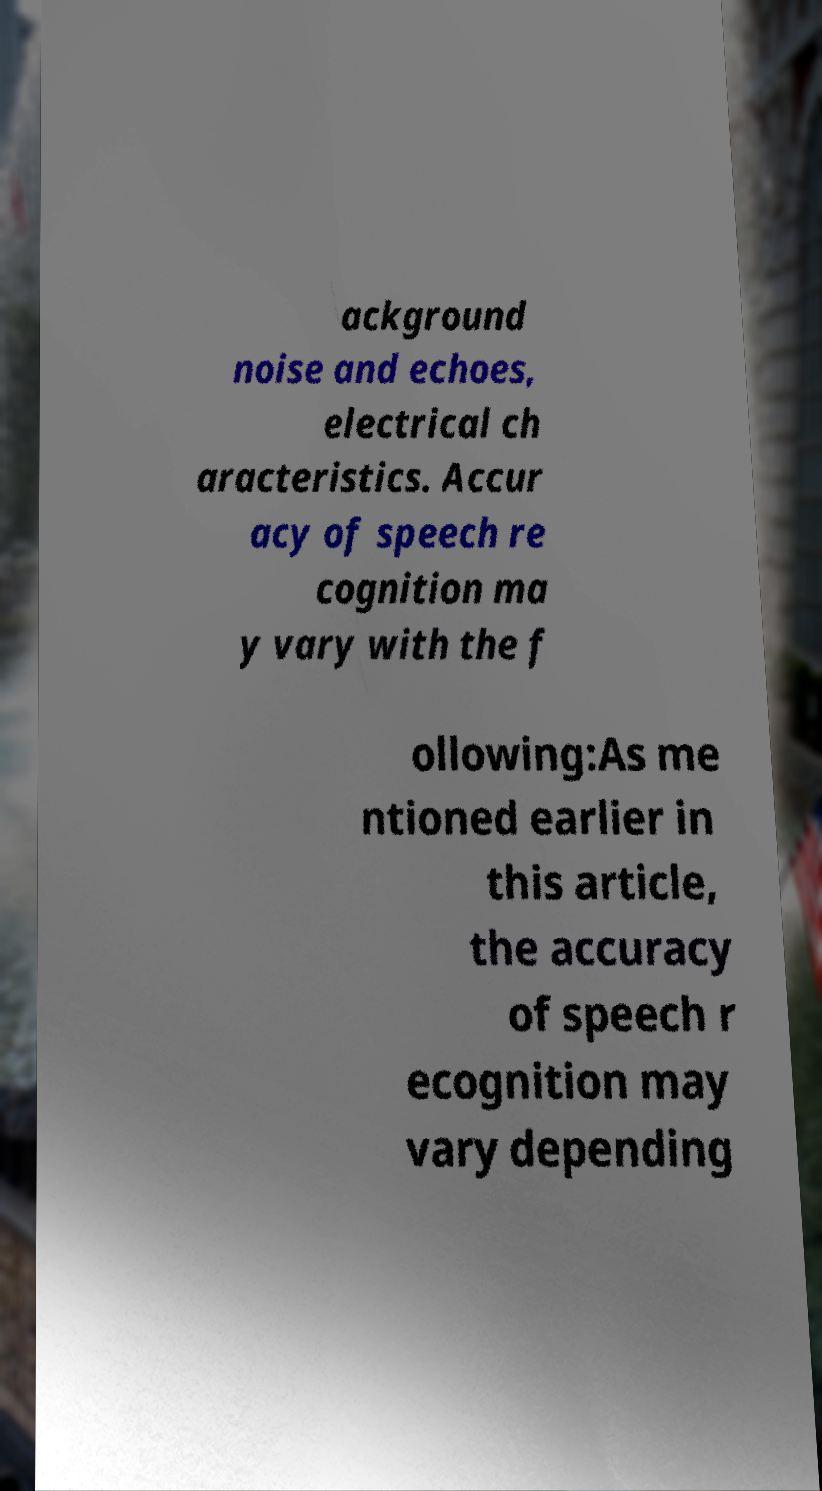Could you assist in decoding the text presented in this image and type it out clearly? ackground noise and echoes, electrical ch aracteristics. Accur acy of speech re cognition ma y vary with the f ollowing:As me ntioned earlier in this article, the accuracy of speech r ecognition may vary depending 